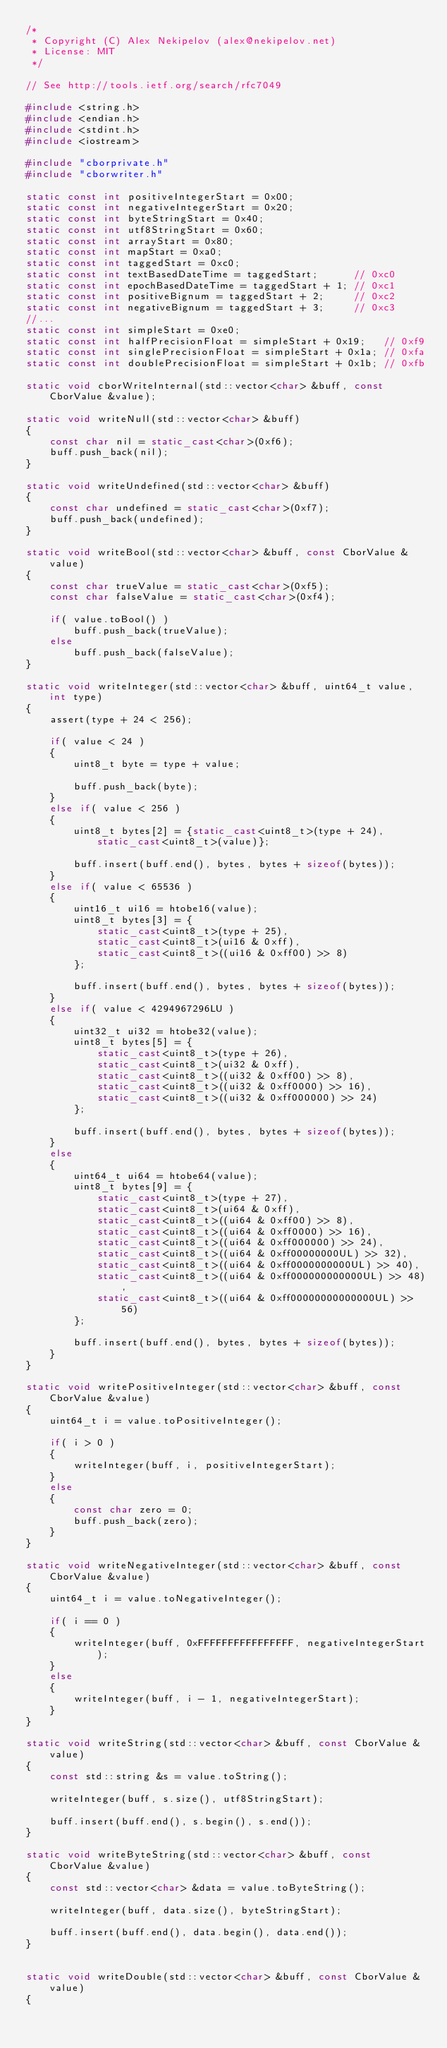<code> <loc_0><loc_0><loc_500><loc_500><_C++_>/*
 * Copyright (C) Alex Nekipelov (alex@nekipelov.net)
 * License: MIT
 */

// See http://tools.ietf.org/search/rfc7049

#include <string.h>
#include <endian.h>
#include <stdint.h>
#include <iostream>

#include "cborprivate.h"
#include "cborwriter.h"

static const int positiveIntegerStart = 0x00;
static const int negativeIntegerStart = 0x20;
static const int byteStringStart = 0x40;
static const int utf8StringStart = 0x60;
static const int arrayStart = 0x80;
static const int mapStart = 0xa0;
static const int taggedStart = 0xc0;
static const int textBasedDateTime = taggedStart;      // 0xc0
static const int epochBasedDateTime = taggedStart + 1; // 0xc1
static const int positiveBignum = taggedStart + 2;     // 0xc2
static const int negativeBignum = taggedStart + 3;     // 0xc3
//...
static const int simpleStart = 0xe0;
static const int halfPrecisionFloat = simpleStart + 0x19;   // 0xf9
static const int singlePrecisionFloat = simpleStart + 0x1a; // 0xfa
static const int doublePrecisionFloat = simpleStart + 0x1b; // 0xfb

static void cborWriteInternal(std::vector<char> &buff, const CborValue &value);

static void writeNull(std::vector<char> &buff)
{
    const char nil = static_cast<char>(0xf6);
    buff.push_back(nil);
}

static void writeUndefined(std::vector<char> &buff)
{
    const char undefined = static_cast<char>(0xf7);
    buff.push_back(undefined);
}

static void writeBool(std::vector<char> &buff, const CborValue &value)
{
    const char trueValue = static_cast<char>(0xf5);
    const char falseValue = static_cast<char>(0xf4);

    if( value.toBool() )
        buff.push_back(trueValue);
    else
        buff.push_back(falseValue);
}

static void writeInteger(std::vector<char> &buff, uint64_t value, int type)
{
    assert(type + 24 < 256);

    if( value < 24 )
    {
        uint8_t byte = type + value;

        buff.push_back(byte);
    }
    else if( value < 256 )
    {
        uint8_t bytes[2] = {static_cast<uint8_t>(type + 24), static_cast<uint8_t>(value)};

        buff.insert(buff.end(), bytes, bytes + sizeof(bytes));
    }
    else if( value < 65536 )
    {
        uint16_t ui16 = htobe16(value);
        uint8_t bytes[3] = {
            static_cast<uint8_t>(type + 25),
            static_cast<uint8_t>(ui16 & 0xff),
            static_cast<uint8_t>((ui16 & 0xff00) >> 8)
        };

        buff.insert(buff.end(), bytes, bytes + sizeof(bytes));
    }
    else if( value < 4294967296LU )
    {
        uint32_t ui32 = htobe32(value);
        uint8_t bytes[5] = {
            static_cast<uint8_t>(type + 26),
            static_cast<uint8_t>(ui32 & 0xff),
            static_cast<uint8_t>((ui32 & 0xff00) >> 8),
            static_cast<uint8_t>((ui32 & 0xff0000) >> 16),
            static_cast<uint8_t>((ui32 & 0xff000000) >> 24)
        };

        buff.insert(buff.end(), bytes, bytes + sizeof(bytes));
    }
    else
    {
        uint64_t ui64 = htobe64(value);
        uint8_t bytes[9] = {
            static_cast<uint8_t>(type + 27),
            static_cast<uint8_t>(ui64 & 0xff),
            static_cast<uint8_t>((ui64 & 0xff00) >> 8),
            static_cast<uint8_t>((ui64 & 0xff0000) >> 16),
            static_cast<uint8_t>((ui64 & 0xff000000) >> 24),
            static_cast<uint8_t>((ui64 & 0xff00000000UL) >> 32),
            static_cast<uint8_t>((ui64 & 0xff0000000000UL) >> 40),
            static_cast<uint8_t>((ui64 & 0xff000000000000UL) >> 48),
            static_cast<uint8_t>((ui64 & 0xff00000000000000UL) >> 56)
        };

        buff.insert(buff.end(), bytes, bytes + sizeof(bytes));
    }
}

static void writePositiveInteger(std::vector<char> &buff, const CborValue &value)
{
    uint64_t i = value.toPositiveInteger();

    if( i > 0 )
    {
        writeInteger(buff, i, positiveIntegerStart);
    }
    else
    {
        const char zero = 0;
        buff.push_back(zero);
    }
}

static void writeNegativeInteger(std::vector<char> &buff, const CborValue &value)
{
    uint64_t i = value.toNegativeInteger();

    if( i == 0 )
    {
        writeInteger(buff, 0xFFFFFFFFFFFFFFFF, negativeIntegerStart);
    }
    else
    {
        writeInteger(buff, i - 1, negativeIntegerStart);
    }
}

static void writeString(std::vector<char> &buff, const CborValue &value)
{
    const std::string &s = value.toString();

    writeInteger(buff, s.size(), utf8StringStart);

    buff.insert(buff.end(), s.begin(), s.end());
}

static void writeByteString(std::vector<char> &buff, const CborValue &value)
{
    const std::vector<char> &data = value.toByteString();

    writeInteger(buff, data.size(), byteStringStart);

    buff.insert(buff.end(), data.begin(), data.end());
}


static void writeDouble(std::vector<char> &buff, const CborValue &value)
{</code> 